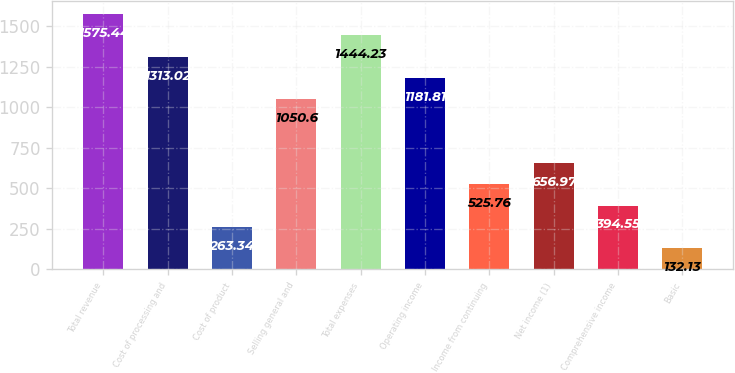Convert chart to OTSL. <chart><loc_0><loc_0><loc_500><loc_500><bar_chart><fcel>Total revenue<fcel>Cost of processing and<fcel>Cost of product<fcel>Selling general and<fcel>Total expenses<fcel>Operating income<fcel>Income from continuing<fcel>Net income (1)<fcel>Comprehensive income<fcel>Basic<nl><fcel>1575.44<fcel>1313.02<fcel>263.34<fcel>1050.6<fcel>1444.23<fcel>1181.81<fcel>525.76<fcel>656.97<fcel>394.55<fcel>132.13<nl></chart> 